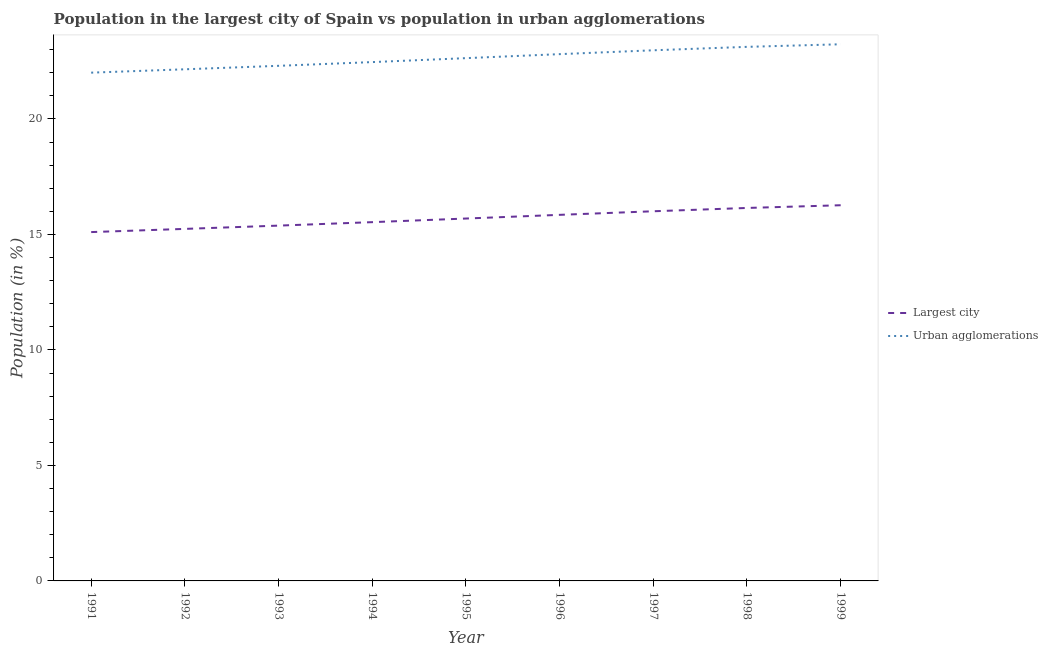What is the population in urban agglomerations in 1995?
Provide a short and direct response. 22.63. Across all years, what is the maximum population in urban agglomerations?
Your answer should be compact. 23.23. Across all years, what is the minimum population in urban agglomerations?
Keep it short and to the point. 22.01. In which year was the population in urban agglomerations maximum?
Your answer should be very brief. 1999. In which year was the population in urban agglomerations minimum?
Give a very brief answer. 1991. What is the total population in urban agglomerations in the graph?
Your answer should be very brief. 203.69. What is the difference between the population in urban agglomerations in 1992 and that in 1997?
Your answer should be compact. -0.82. What is the difference between the population in urban agglomerations in 1992 and the population in the largest city in 1995?
Your answer should be very brief. 6.46. What is the average population in the largest city per year?
Give a very brief answer. 15.69. In the year 1999, what is the difference between the population in urban agglomerations and population in the largest city?
Offer a terse response. 6.97. In how many years, is the population in urban agglomerations greater than 19 %?
Provide a short and direct response. 9. What is the ratio of the population in the largest city in 1991 to that in 1993?
Offer a very short reply. 0.98. Is the difference between the population in urban agglomerations in 1991 and 1998 greater than the difference between the population in the largest city in 1991 and 1998?
Offer a terse response. No. What is the difference between the highest and the second highest population in the largest city?
Keep it short and to the point. 0.12. What is the difference between the highest and the lowest population in urban agglomerations?
Your answer should be very brief. 1.23. Does the population in urban agglomerations monotonically increase over the years?
Your response must be concise. Yes. Is the population in urban agglomerations strictly less than the population in the largest city over the years?
Provide a short and direct response. No. How many years are there in the graph?
Your answer should be very brief. 9. What is the difference between two consecutive major ticks on the Y-axis?
Keep it short and to the point. 5. Are the values on the major ticks of Y-axis written in scientific E-notation?
Provide a succinct answer. No. Does the graph contain any zero values?
Provide a short and direct response. No. Does the graph contain grids?
Keep it short and to the point. No. Where does the legend appear in the graph?
Make the answer very short. Center right. What is the title of the graph?
Offer a terse response. Population in the largest city of Spain vs population in urban agglomerations. Does "Public credit registry" appear as one of the legend labels in the graph?
Make the answer very short. No. What is the Population (in %) of Largest city in 1991?
Give a very brief answer. 15.1. What is the Population (in %) in Urban agglomerations in 1991?
Keep it short and to the point. 22.01. What is the Population (in %) in Largest city in 1992?
Your response must be concise. 15.24. What is the Population (in %) of Urban agglomerations in 1992?
Keep it short and to the point. 22.15. What is the Population (in %) of Largest city in 1993?
Make the answer very short. 15.38. What is the Population (in %) of Urban agglomerations in 1993?
Keep it short and to the point. 22.3. What is the Population (in %) in Largest city in 1994?
Your response must be concise. 15.53. What is the Population (in %) in Urban agglomerations in 1994?
Offer a very short reply. 22.46. What is the Population (in %) in Largest city in 1995?
Give a very brief answer. 15.69. What is the Population (in %) in Urban agglomerations in 1995?
Provide a short and direct response. 22.63. What is the Population (in %) of Largest city in 1996?
Ensure brevity in your answer.  15.85. What is the Population (in %) in Urban agglomerations in 1996?
Provide a short and direct response. 22.81. What is the Population (in %) in Largest city in 1997?
Keep it short and to the point. 16. What is the Population (in %) in Urban agglomerations in 1997?
Make the answer very short. 22.97. What is the Population (in %) in Largest city in 1998?
Offer a very short reply. 16.15. What is the Population (in %) in Urban agglomerations in 1998?
Provide a short and direct response. 23.12. What is the Population (in %) in Largest city in 1999?
Offer a terse response. 16.27. What is the Population (in %) of Urban agglomerations in 1999?
Your answer should be compact. 23.23. Across all years, what is the maximum Population (in %) in Largest city?
Keep it short and to the point. 16.27. Across all years, what is the maximum Population (in %) in Urban agglomerations?
Your answer should be compact. 23.23. Across all years, what is the minimum Population (in %) of Largest city?
Your answer should be compact. 15.1. Across all years, what is the minimum Population (in %) of Urban agglomerations?
Provide a short and direct response. 22.01. What is the total Population (in %) of Largest city in the graph?
Ensure brevity in your answer.  141.22. What is the total Population (in %) in Urban agglomerations in the graph?
Your response must be concise. 203.69. What is the difference between the Population (in %) of Largest city in 1991 and that in 1992?
Make the answer very short. -0.14. What is the difference between the Population (in %) in Urban agglomerations in 1991 and that in 1992?
Give a very brief answer. -0.15. What is the difference between the Population (in %) of Largest city in 1991 and that in 1993?
Provide a succinct answer. -0.28. What is the difference between the Population (in %) of Urban agglomerations in 1991 and that in 1993?
Give a very brief answer. -0.3. What is the difference between the Population (in %) in Largest city in 1991 and that in 1994?
Ensure brevity in your answer.  -0.43. What is the difference between the Population (in %) in Urban agglomerations in 1991 and that in 1994?
Your answer should be very brief. -0.46. What is the difference between the Population (in %) in Largest city in 1991 and that in 1995?
Your answer should be very brief. -0.59. What is the difference between the Population (in %) in Urban agglomerations in 1991 and that in 1995?
Keep it short and to the point. -0.63. What is the difference between the Population (in %) of Largest city in 1991 and that in 1996?
Give a very brief answer. -0.75. What is the difference between the Population (in %) in Urban agglomerations in 1991 and that in 1996?
Your answer should be compact. -0.8. What is the difference between the Population (in %) of Largest city in 1991 and that in 1997?
Your answer should be very brief. -0.9. What is the difference between the Population (in %) in Urban agglomerations in 1991 and that in 1997?
Offer a very short reply. -0.97. What is the difference between the Population (in %) of Largest city in 1991 and that in 1998?
Offer a very short reply. -1.04. What is the difference between the Population (in %) in Urban agglomerations in 1991 and that in 1998?
Provide a short and direct response. -1.12. What is the difference between the Population (in %) in Largest city in 1991 and that in 1999?
Keep it short and to the point. -1.16. What is the difference between the Population (in %) in Urban agglomerations in 1991 and that in 1999?
Your answer should be compact. -1.23. What is the difference between the Population (in %) in Largest city in 1992 and that in 1993?
Offer a terse response. -0.14. What is the difference between the Population (in %) of Urban agglomerations in 1992 and that in 1993?
Keep it short and to the point. -0.15. What is the difference between the Population (in %) in Largest city in 1992 and that in 1994?
Make the answer very short. -0.29. What is the difference between the Population (in %) of Urban agglomerations in 1992 and that in 1994?
Give a very brief answer. -0.31. What is the difference between the Population (in %) in Largest city in 1992 and that in 1995?
Your answer should be compact. -0.45. What is the difference between the Population (in %) in Urban agglomerations in 1992 and that in 1995?
Your answer should be very brief. -0.48. What is the difference between the Population (in %) of Largest city in 1992 and that in 1996?
Provide a succinct answer. -0.61. What is the difference between the Population (in %) of Urban agglomerations in 1992 and that in 1996?
Make the answer very short. -0.66. What is the difference between the Population (in %) in Largest city in 1992 and that in 1997?
Your response must be concise. -0.76. What is the difference between the Population (in %) in Urban agglomerations in 1992 and that in 1997?
Offer a very short reply. -0.82. What is the difference between the Population (in %) in Largest city in 1992 and that in 1998?
Make the answer very short. -0.91. What is the difference between the Population (in %) of Urban agglomerations in 1992 and that in 1998?
Ensure brevity in your answer.  -0.97. What is the difference between the Population (in %) in Largest city in 1992 and that in 1999?
Your answer should be very brief. -1.02. What is the difference between the Population (in %) of Urban agglomerations in 1992 and that in 1999?
Provide a short and direct response. -1.08. What is the difference between the Population (in %) of Largest city in 1993 and that in 1994?
Ensure brevity in your answer.  -0.15. What is the difference between the Population (in %) in Urban agglomerations in 1993 and that in 1994?
Offer a very short reply. -0.16. What is the difference between the Population (in %) of Largest city in 1993 and that in 1995?
Offer a very short reply. -0.31. What is the difference between the Population (in %) of Urban agglomerations in 1993 and that in 1995?
Provide a short and direct response. -0.33. What is the difference between the Population (in %) of Largest city in 1993 and that in 1996?
Your answer should be very brief. -0.47. What is the difference between the Population (in %) in Urban agglomerations in 1993 and that in 1996?
Give a very brief answer. -0.51. What is the difference between the Population (in %) of Largest city in 1993 and that in 1997?
Your answer should be compact. -0.62. What is the difference between the Population (in %) of Urban agglomerations in 1993 and that in 1997?
Offer a terse response. -0.67. What is the difference between the Population (in %) in Largest city in 1993 and that in 1998?
Keep it short and to the point. -0.76. What is the difference between the Population (in %) in Urban agglomerations in 1993 and that in 1998?
Provide a short and direct response. -0.82. What is the difference between the Population (in %) in Largest city in 1993 and that in 1999?
Keep it short and to the point. -0.88. What is the difference between the Population (in %) in Urban agglomerations in 1993 and that in 1999?
Ensure brevity in your answer.  -0.93. What is the difference between the Population (in %) in Largest city in 1994 and that in 1995?
Make the answer very short. -0.16. What is the difference between the Population (in %) in Urban agglomerations in 1994 and that in 1995?
Provide a short and direct response. -0.17. What is the difference between the Population (in %) of Largest city in 1994 and that in 1996?
Offer a very short reply. -0.32. What is the difference between the Population (in %) in Urban agglomerations in 1994 and that in 1996?
Make the answer very short. -0.34. What is the difference between the Population (in %) of Largest city in 1994 and that in 1997?
Your answer should be compact. -0.47. What is the difference between the Population (in %) of Urban agglomerations in 1994 and that in 1997?
Your response must be concise. -0.51. What is the difference between the Population (in %) of Largest city in 1994 and that in 1998?
Make the answer very short. -0.61. What is the difference between the Population (in %) of Urban agglomerations in 1994 and that in 1998?
Offer a very short reply. -0.66. What is the difference between the Population (in %) of Largest city in 1994 and that in 1999?
Offer a very short reply. -0.73. What is the difference between the Population (in %) in Urban agglomerations in 1994 and that in 1999?
Your answer should be very brief. -0.77. What is the difference between the Population (in %) in Largest city in 1995 and that in 1996?
Keep it short and to the point. -0.16. What is the difference between the Population (in %) of Urban agglomerations in 1995 and that in 1996?
Keep it short and to the point. -0.17. What is the difference between the Population (in %) of Largest city in 1995 and that in 1997?
Provide a succinct answer. -0.31. What is the difference between the Population (in %) in Urban agglomerations in 1995 and that in 1997?
Your answer should be very brief. -0.34. What is the difference between the Population (in %) in Largest city in 1995 and that in 1998?
Provide a short and direct response. -0.46. What is the difference between the Population (in %) of Urban agglomerations in 1995 and that in 1998?
Ensure brevity in your answer.  -0.49. What is the difference between the Population (in %) of Largest city in 1995 and that in 1999?
Provide a short and direct response. -0.58. What is the difference between the Population (in %) of Urban agglomerations in 1995 and that in 1999?
Your answer should be very brief. -0.6. What is the difference between the Population (in %) of Largest city in 1996 and that in 1997?
Your answer should be compact. -0.16. What is the difference between the Population (in %) of Urban agglomerations in 1996 and that in 1997?
Offer a terse response. -0.17. What is the difference between the Population (in %) of Largest city in 1996 and that in 1998?
Your answer should be very brief. -0.3. What is the difference between the Population (in %) of Urban agglomerations in 1996 and that in 1998?
Your answer should be very brief. -0.32. What is the difference between the Population (in %) of Largest city in 1996 and that in 1999?
Offer a very short reply. -0.42. What is the difference between the Population (in %) of Urban agglomerations in 1996 and that in 1999?
Offer a terse response. -0.43. What is the difference between the Population (in %) in Largest city in 1997 and that in 1998?
Your answer should be very brief. -0.14. What is the difference between the Population (in %) in Urban agglomerations in 1997 and that in 1998?
Give a very brief answer. -0.15. What is the difference between the Population (in %) of Largest city in 1997 and that in 1999?
Your answer should be compact. -0.26. What is the difference between the Population (in %) in Urban agglomerations in 1997 and that in 1999?
Your response must be concise. -0.26. What is the difference between the Population (in %) of Largest city in 1998 and that in 1999?
Your response must be concise. -0.12. What is the difference between the Population (in %) in Urban agglomerations in 1998 and that in 1999?
Give a very brief answer. -0.11. What is the difference between the Population (in %) in Largest city in 1991 and the Population (in %) in Urban agglomerations in 1992?
Your answer should be very brief. -7.05. What is the difference between the Population (in %) of Largest city in 1991 and the Population (in %) of Urban agglomerations in 1993?
Ensure brevity in your answer.  -7.2. What is the difference between the Population (in %) of Largest city in 1991 and the Population (in %) of Urban agglomerations in 1994?
Provide a succinct answer. -7.36. What is the difference between the Population (in %) in Largest city in 1991 and the Population (in %) in Urban agglomerations in 1995?
Your answer should be compact. -7.53. What is the difference between the Population (in %) of Largest city in 1991 and the Population (in %) of Urban agglomerations in 1996?
Keep it short and to the point. -7.7. What is the difference between the Population (in %) in Largest city in 1991 and the Population (in %) in Urban agglomerations in 1997?
Offer a terse response. -7.87. What is the difference between the Population (in %) of Largest city in 1991 and the Population (in %) of Urban agglomerations in 1998?
Give a very brief answer. -8.02. What is the difference between the Population (in %) of Largest city in 1991 and the Population (in %) of Urban agglomerations in 1999?
Offer a terse response. -8.13. What is the difference between the Population (in %) of Largest city in 1992 and the Population (in %) of Urban agglomerations in 1993?
Your response must be concise. -7.06. What is the difference between the Population (in %) in Largest city in 1992 and the Population (in %) in Urban agglomerations in 1994?
Give a very brief answer. -7.22. What is the difference between the Population (in %) in Largest city in 1992 and the Population (in %) in Urban agglomerations in 1995?
Ensure brevity in your answer.  -7.39. What is the difference between the Population (in %) in Largest city in 1992 and the Population (in %) in Urban agglomerations in 1996?
Your response must be concise. -7.57. What is the difference between the Population (in %) in Largest city in 1992 and the Population (in %) in Urban agglomerations in 1997?
Your response must be concise. -7.73. What is the difference between the Population (in %) of Largest city in 1992 and the Population (in %) of Urban agglomerations in 1998?
Offer a terse response. -7.88. What is the difference between the Population (in %) of Largest city in 1992 and the Population (in %) of Urban agglomerations in 1999?
Provide a succinct answer. -7.99. What is the difference between the Population (in %) in Largest city in 1993 and the Population (in %) in Urban agglomerations in 1994?
Provide a short and direct response. -7.08. What is the difference between the Population (in %) of Largest city in 1993 and the Population (in %) of Urban agglomerations in 1995?
Offer a very short reply. -7.25. What is the difference between the Population (in %) in Largest city in 1993 and the Population (in %) in Urban agglomerations in 1996?
Offer a terse response. -7.42. What is the difference between the Population (in %) in Largest city in 1993 and the Population (in %) in Urban agglomerations in 1997?
Offer a terse response. -7.59. What is the difference between the Population (in %) of Largest city in 1993 and the Population (in %) of Urban agglomerations in 1998?
Make the answer very short. -7.74. What is the difference between the Population (in %) in Largest city in 1993 and the Population (in %) in Urban agglomerations in 1999?
Your answer should be very brief. -7.85. What is the difference between the Population (in %) in Largest city in 1994 and the Population (in %) in Urban agglomerations in 1995?
Your answer should be compact. -7.1. What is the difference between the Population (in %) of Largest city in 1994 and the Population (in %) of Urban agglomerations in 1996?
Give a very brief answer. -7.27. What is the difference between the Population (in %) of Largest city in 1994 and the Population (in %) of Urban agglomerations in 1997?
Keep it short and to the point. -7.44. What is the difference between the Population (in %) of Largest city in 1994 and the Population (in %) of Urban agglomerations in 1998?
Ensure brevity in your answer.  -7.59. What is the difference between the Population (in %) in Largest city in 1994 and the Population (in %) in Urban agglomerations in 1999?
Make the answer very short. -7.7. What is the difference between the Population (in %) of Largest city in 1995 and the Population (in %) of Urban agglomerations in 1996?
Offer a very short reply. -7.12. What is the difference between the Population (in %) in Largest city in 1995 and the Population (in %) in Urban agglomerations in 1997?
Ensure brevity in your answer.  -7.28. What is the difference between the Population (in %) in Largest city in 1995 and the Population (in %) in Urban agglomerations in 1998?
Your answer should be compact. -7.43. What is the difference between the Population (in %) of Largest city in 1995 and the Population (in %) of Urban agglomerations in 1999?
Make the answer very short. -7.54. What is the difference between the Population (in %) in Largest city in 1996 and the Population (in %) in Urban agglomerations in 1997?
Provide a short and direct response. -7.12. What is the difference between the Population (in %) of Largest city in 1996 and the Population (in %) of Urban agglomerations in 1998?
Provide a succinct answer. -7.27. What is the difference between the Population (in %) of Largest city in 1996 and the Population (in %) of Urban agglomerations in 1999?
Provide a short and direct response. -7.39. What is the difference between the Population (in %) of Largest city in 1997 and the Population (in %) of Urban agglomerations in 1998?
Give a very brief answer. -7.12. What is the difference between the Population (in %) of Largest city in 1997 and the Population (in %) of Urban agglomerations in 1999?
Offer a terse response. -7.23. What is the difference between the Population (in %) in Largest city in 1998 and the Population (in %) in Urban agglomerations in 1999?
Offer a very short reply. -7.09. What is the average Population (in %) of Largest city per year?
Ensure brevity in your answer.  15.69. What is the average Population (in %) of Urban agglomerations per year?
Keep it short and to the point. 22.63. In the year 1991, what is the difference between the Population (in %) of Largest city and Population (in %) of Urban agglomerations?
Provide a short and direct response. -6.9. In the year 1992, what is the difference between the Population (in %) in Largest city and Population (in %) in Urban agglomerations?
Your answer should be very brief. -6.91. In the year 1993, what is the difference between the Population (in %) of Largest city and Population (in %) of Urban agglomerations?
Give a very brief answer. -6.92. In the year 1994, what is the difference between the Population (in %) of Largest city and Population (in %) of Urban agglomerations?
Offer a terse response. -6.93. In the year 1995, what is the difference between the Population (in %) in Largest city and Population (in %) in Urban agglomerations?
Provide a short and direct response. -6.94. In the year 1996, what is the difference between the Population (in %) of Largest city and Population (in %) of Urban agglomerations?
Provide a succinct answer. -6.96. In the year 1997, what is the difference between the Population (in %) of Largest city and Population (in %) of Urban agglomerations?
Ensure brevity in your answer.  -6.97. In the year 1998, what is the difference between the Population (in %) in Largest city and Population (in %) in Urban agglomerations?
Your response must be concise. -6.98. In the year 1999, what is the difference between the Population (in %) of Largest city and Population (in %) of Urban agglomerations?
Offer a very short reply. -6.97. What is the ratio of the Population (in %) of Largest city in 1991 to that in 1992?
Keep it short and to the point. 0.99. What is the ratio of the Population (in %) of Urban agglomerations in 1991 to that in 1992?
Provide a succinct answer. 0.99. What is the ratio of the Population (in %) of Largest city in 1991 to that in 1993?
Make the answer very short. 0.98. What is the ratio of the Population (in %) of Urban agglomerations in 1991 to that in 1993?
Your response must be concise. 0.99. What is the ratio of the Population (in %) in Largest city in 1991 to that in 1994?
Make the answer very short. 0.97. What is the ratio of the Population (in %) in Urban agglomerations in 1991 to that in 1994?
Ensure brevity in your answer.  0.98. What is the ratio of the Population (in %) of Largest city in 1991 to that in 1995?
Offer a very short reply. 0.96. What is the ratio of the Population (in %) in Urban agglomerations in 1991 to that in 1995?
Your response must be concise. 0.97. What is the ratio of the Population (in %) of Largest city in 1991 to that in 1996?
Give a very brief answer. 0.95. What is the ratio of the Population (in %) in Urban agglomerations in 1991 to that in 1996?
Keep it short and to the point. 0.96. What is the ratio of the Population (in %) in Largest city in 1991 to that in 1997?
Offer a very short reply. 0.94. What is the ratio of the Population (in %) in Urban agglomerations in 1991 to that in 1997?
Provide a succinct answer. 0.96. What is the ratio of the Population (in %) in Largest city in 1991 to that in 1998?
Make the answer very short. 0.94. What is the ratio of the Population (in %) in Urban agglomerations in 1991 to that in 1998?
Your response must be concise. 0.95. What is the ratio of the Population (in %) of Largest city in 1991 to that in 1999?
Ensure brevity in your answer.  0.93. What is the ratio of the Population (in %) of Urban agglomerations in 1991 to that in 1999?
Keep it short and to the point. 0.95. What is the ratio of the Population (in %) of Largest city in 1992 to that in 1993?
Ensure brevity in your answer.  0.99. What is the ratio of the Population (in %) of Largest city in 1992 to that in 1994?
Ensure brevity in your answer.  0.98. What is the ratio of the Population (in %) in Urban agglomerations in 1992 to that in 1994?
Provide a succinct answer. 0.99. What is the ratio of the Population (in %) of Largest city in 1992 to that in 1995?
Offer a very short reply. 0.97. What is the ratio of the Population (in %) in Urban agglomerations in 1992 to that in 1995?
Your answer should be very brief. 0.98. What is the ratio of the Population (in %) in Largest city in 1992 to that in 1996?
Your answer should be very brief. 0.96. What is the ratio of the Population (in %) in Urban agglomerations in 1992 to that in 1996?
Your answer should be very brief. 0.97. What is the ratio of the Population (in %) in Largest city in 1992 to that in 1997?
Give a very brief answer. 0.95. What is the ratio of the Population (in %) of Urban agglomerations in 1992 to that in 1997?
Your response must be concise. 0.96. What is the ratio of the Population (in %) in Largest city in 1992 to that in 1998?
Your answer should be very brief. 0.94. What is the ratio of the Population (in %) in Urban agglomerations in 1992 to that in 1998?
Provide a succinct answer. 0.96. What is the ratio of the Population (in %) in Largest city in 1992 to that in 1999?
Give a very brief answer. 0.94. What is the ratio of the Population (in %) in Urban agglomerations in 1992 to that in 1999?
Make the answer very short. 0.95. What is the ratio of the Population (in %) in Largest city in 1993 to that in 1994?
Give a very brief answer. 0.99. What is the ratio of the Population (in %) in Urban agglomerations in 1993 to that in 1994?
Your answer should be compact. 0.99. What is the ratio of the Population (in %) of Largest city in 1993 to that in 1995?
Provide a succinct answer. 0.98. What is the ratio of the Population (in %) of Largest city in 1993 to that in 1996?
Give a very brief answer. 0.97. What is the ratio of the Population (in %) in Urban agglomerations in 1993 to that in 1996?
Offer a very short reply. 0.98. What is the ratio of the Population (in %) of Largest city in 1993 to that in 1997?
Offer a very short reply. 0.96. What is the ratio of the Population (in %) in Urban agglomerations in 1993 to that in 1997?
Offer a very short reply. 0.97. What is the ratio of the Population (in %) of Largest city in 1993 to that in 1998?
Your answer should be very brief. 0.95. What is the ratio of the Population (in %) of Urban agglomerations in 1993 to that in 1998?
Your answer should be very brief. 0.96. What is the ratio of the Population (in %) of Largest city in 1993 to that in 1999?
Provide a short and direct response. 0.95. What is the ratio of the Population (in %) in Urban agglomerations in 1993 to that in 1999?
Give a very brief answer. 0.96. What is the ratio of the Population (in %) in Largest city in 1994 to that in 1996?
Your answer should be compact. 0.98. What is the ratio of the Population (in %) of Urban agglomerations in 1994 to that in 1996?
Keep it short and to the point. 0.98. What is the ratio of the Population (in %) of Largest city in 1994 to that in 1997?
Your answer should be very brief. 0.97. What is the ratio of the Population (in %) of Urban agglomerations in 1994 to that in 1997?
Offer a very short reply. 0.98. What is the ratio of the Population (in %) of Largest city in 1994 to that in 1998?
Offer a very short reply. 0.96. What is the ratio of the Population (in %) in Urban agglomerations in 1994 to that in 1998?
Provide a short and direct response. 0.97. What is the ratio of the Population (in %) of Largest city in 1994 to that in 1999?
Your answer should be very brief. 0.95. What is the ratio of the Population (in %) of Urban agglomerations in 1994 to that in 1999?
Make the answer very short. 0.97. What is the ratio of the Population (in %) in Largest city in 1995 to that in 1996?
Give a very brief answer. 0.99. What is the ratio of the Population (in %) in Urban agglomerations in 1995 to that in 1996?
Make the answer very short. 0.99. What is the ratio of the Population (in %) of Largest city in 1995 to that in 1997?
Give a very brief answer. 0.98. What is the ratio of the Population (in %) in Urban agglomerations in 1995 to that in 1997?
Keep it short and to the point. 0.99. What is the ratio of the Population (in %) of Largest city in 1995 to that in 1998?
Offer a very short reply. 0.97. What is the ratio of the Population (in %) of Urban agglomerations in 1995 to that in 1998?
Your answer should be very brief. 0.98. What is the ratio of the Population (in %) of Largest city in 1995 to that in 1999?
Your answer should be very brief. 0.96. What is the ratio of the Population (in %) in Urban agglomerations in 1995 to that in 1999?
Provide a short and direct response. 0.97. What is the ratio of the Population (in %) of Largest city in 1996 to that in 1997?
Make the answer very short. 0.99. What is the ratio of the Population (in %) in Largest city in 1996 to that in 1998?
Ensure brevity in your answer.  0.98. What is the ratio of the Population (in %) in Urban agglomerations in 1996 to that in 1998?
Ensure brevity in your answer.  0.99. What is the ratio of the Population (in %) in Largest city in 1996 to that in 1999?
Keep it short and to the point. 0.97. What is the ratio of the Population (in %) in Urban agglomerations in 1996 to that in 1999?
Keep it short and to the point. 0.98. What is the ratio of the Population (in %) of Largest city in 1997 to that in 1998?
Provide a succinct answer. 0.99. What is the ratio of the Population (in %) of Urban agglomerations in 1997 to that in 1998?
Your response must be concise. 0.99. What is the ratio of the Population (in %) in Urban agglomerations in 1998 to that in 1999?
Give a very brief answer. 1. What is the difference between the highest and the second highest Population (in %) of Largest city?
Make the answer very short. 0.12. What is the difference between the highest and the second highest Population (in %) in Urban agglomerations?
Provide a succinct answer. 0.11. What is the difference between the highest and the lowest Population (in %) of Largest city?
Offer a terse response. 1.16. What is the difference between the highest and the lowest Population (in %) in Urban agglomerations?
Keep it short and to the point. 1.23. 